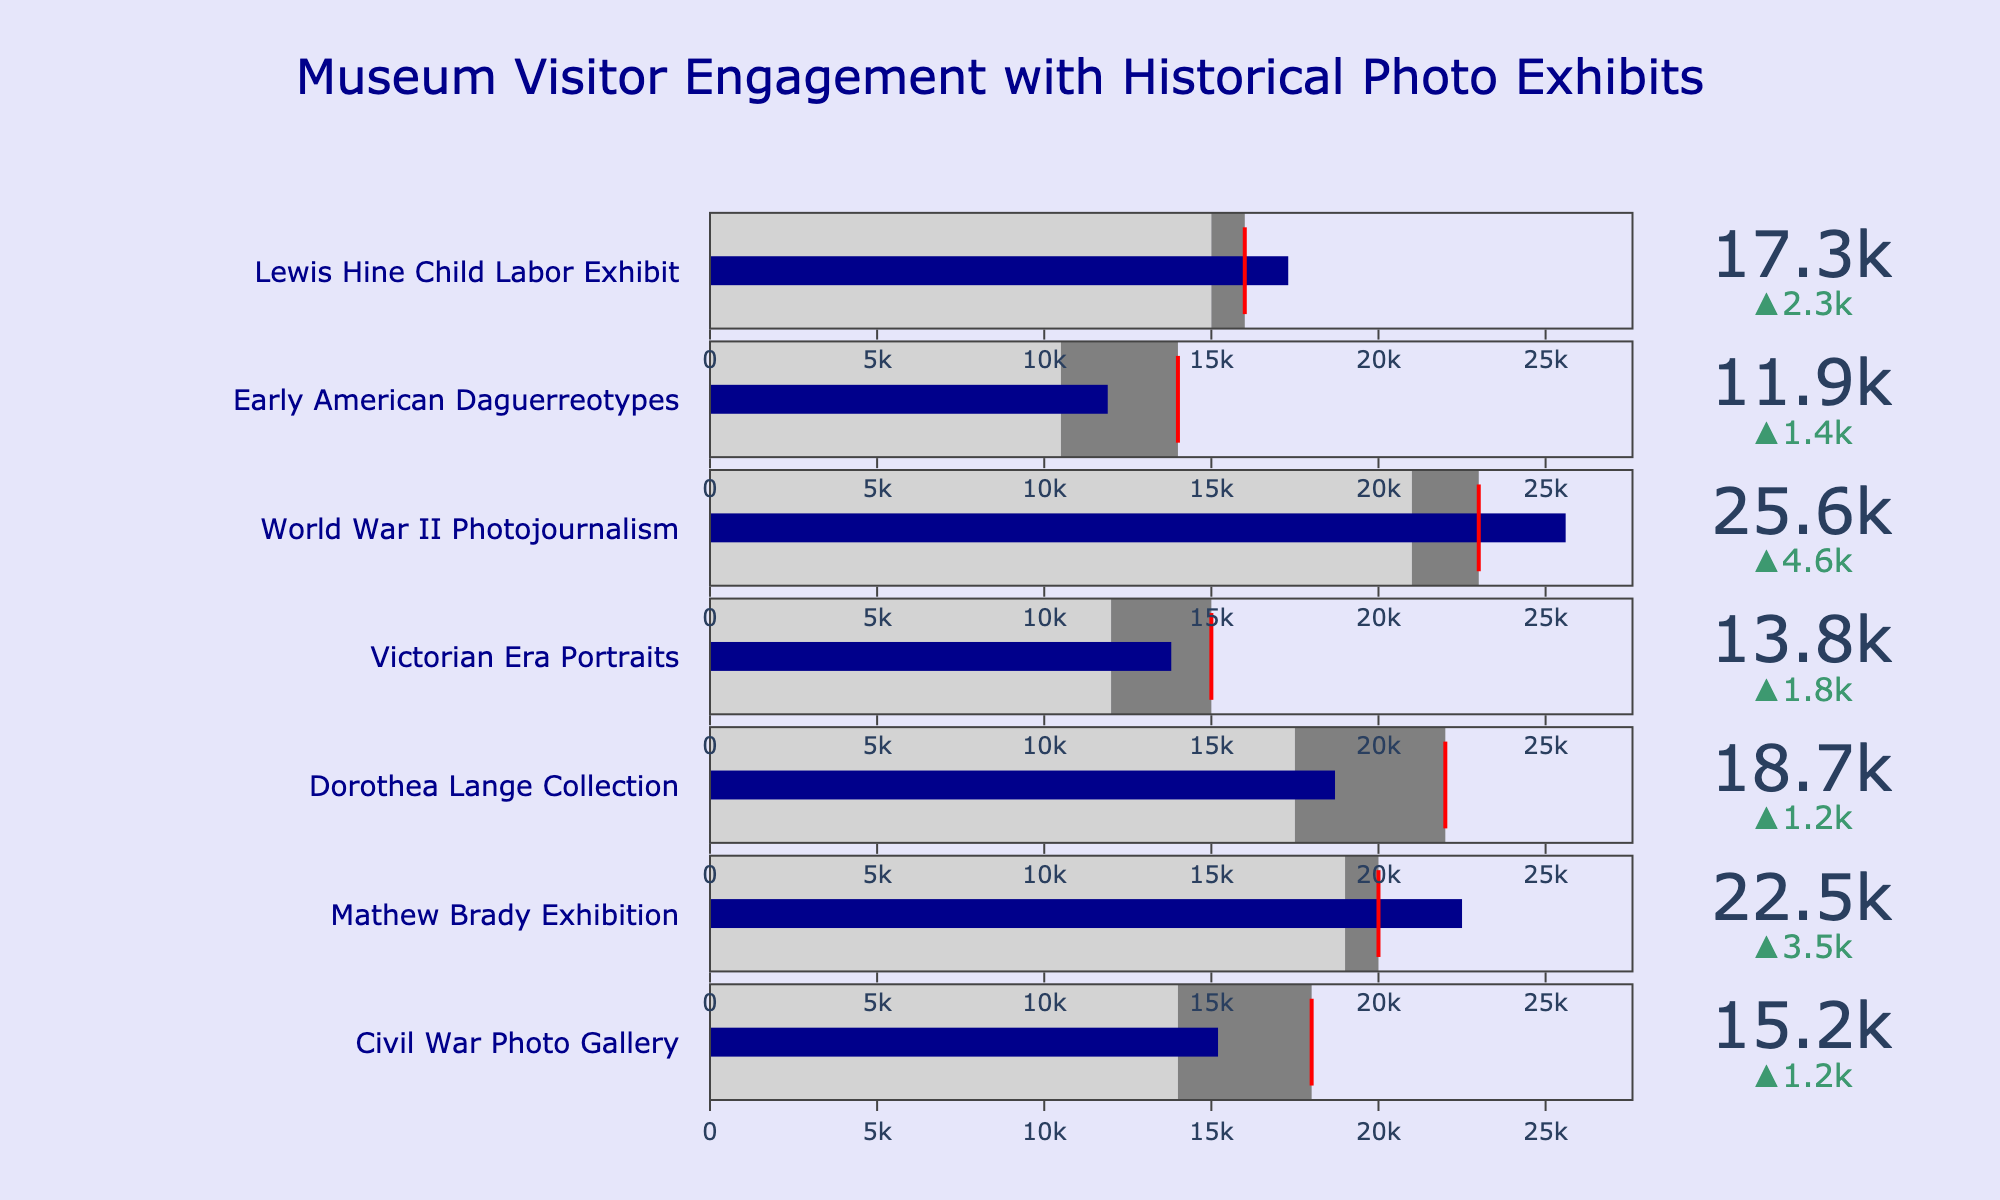What is the title of the figure? The title of the figure is presented at the top and usually provides an overview of what the figure represents. In this case, it specifically mentions the subject being analyzed.
Answer: Museum Visitor Engagement with Historical Photo Exhibits How many museum exhibits are shown in the figure? By counting the different museum names listed on the y-axis or in the bullet charts, one can determine the total number of exhibits represented.
Answer: 7 Which exhibit had the highest number of actual visitors? By assessing the values indicated by the blue bars in the bullet charts, one can identify the exhibit with the highest value for actual visitors.
Answer: World War II Photojournalism Which exhibit's actual visitors were the closest to reaching its target visitors? Compare the actual visitors represented by the blue bars with the target thresholds represented by red lines for each exhibit to find the one where these values are closest.
Answer: Mathew Brady Exhibition How much higher were the actual visitors compared to the historical average for the Dorothea Lange Collection? Calculate the difference between the actual number of visitors and the historical average for the specified exhibit.
Answer: 1200 (18700 - 17500) Did any exhibit surpass its target visitors? Checking each bullet chart for actual visitors exceeding the red threshold line will determine if any exhibit's actual visitors were higher than their target.
Answer: Yes Which exhibit had the largest gap between actual visitors and target visitors? Calculate the difference between the actual visitors and the target visitors for each exhibit to find the one with the widest gap.
Answer: Dorothea Lange Collection What is the average number of target visitors across all exhibits? Sum the target visitors for all exhibits and divide by the total number of exhibits (7 in this case).
Answer: 18214 Which exhibit saw the greatest improvement in visitors compared to its historical average? Calculate the difference between the actual visitors and the historical average for each exhibit and then identify the largest improvement.
Answer: World War II Photojournalism What was the target number of visitors for the Early American Daguerreotypes exhibit? Check the value marked by the red line in the bullet chart for the specified exhibit.
Answer: 14000 